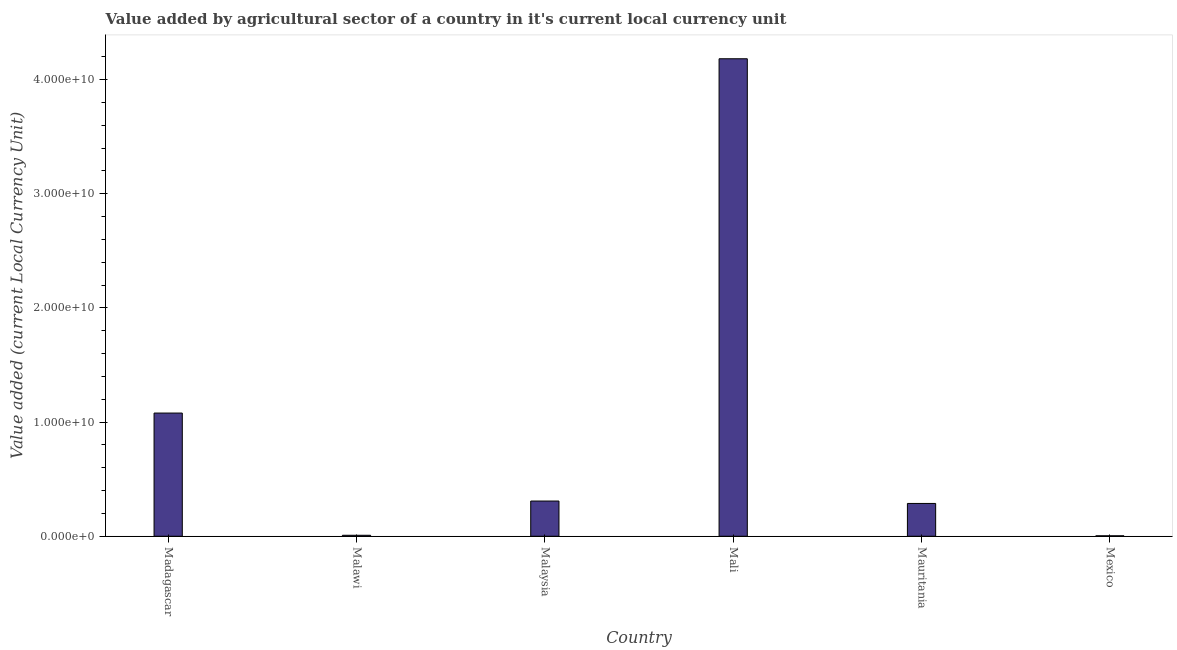Does the graph contain any zero values?
Provide a short and direct response. No. Does the graph contain grids?
Offer a terse response. No. What is the title of the graph?
Give a very brief answer. Value added by agricultural sector of a country in it's current local currency unit. What is the label or title of the X-axis?
Offer a terse response. Country. What is the label or title of the Y-axis?
Keep it short and to the point. Value added (current Local Currency Unit). What is the value added by agriculture sector in Mali?
Offer a very short reply. 4.18e+1. Across all countries, what is the maximum value added by agriculture sector?
Your answer should be very brief. 4.18e+1. Across all countries, what is the minimum value added by agriculture sector?
Make the answer very short. 3.90e+07. In which country was the value added by agriculture sector maximum?
Offer a very short reply. Mali. What is the sum of the value added by agriculture sector?
Your response must be concise. 5.87e+1. What is the difference between the value added by agriculture sector in Malawi and Mexico?
Your answer should be compact. 4.70e+07. What is the average value added by agriculture sector per country?
Offer a very short reply. 9.78e+09. What is the median value added by agriculture sector?
Your answer should be compact. 2.98e+09. In how many countries, is the value added by agriculture sector greater than 22000000000 LCU?
Give a very brief answer. 1. What is the ratio of the value added by agriculture sector in Malawi to that in Mexico?
Provide a short and direct response. 2.21. Is the value added by agriculture sector in Madagascar less than that in Malawi?
Provide a succinct answer. No. What is the difference between the highest and the second highest value added by agriculture sector?
Provide a succinct answer. 3.10e+1. What is the difference between the highest and the lowest value added by agriculture sector?
Ensure brevity in your answer.  4.18e+1. Are all the bars in the graph horizontal?
Your answer should be very brief. No. What is the difference between two consecutive major ticks on the Y-axis?
Offer a terse response. 1.00e+1. What is the Value added (current Local Currency Unit) in Madagascar?
Ensure brevity in your answer.  1.08e+1. What is the Value added (current Local Currency Unit) in Malawi?
Make the answer very short. 8.60e+07. What is the Value added (current Local Currency Unit) of Malaysia?
Give a very brief answer. 3.08e+09. What is the Value added (current Local Currency Unit) in Mali?
Provide a succinct answer. 4.18e+1. What is the Value added (current Local Currency Unit) in Mauritania?
Keep it short and to the point. 2.87e+09. What is the Value added (current Local Currency Unit) of Mexico?
Your answer should be very brief. 3.90e+07. What is the difference between the Value added (current Local Currency Unit) in Madagascar and Malawi?
Offer a very short reply. 1.07e+1. What is the difference between the Value added (current Local Currency Unit) in Madagascar and Malaysia?
Provide a short and direct response. 7.71e+09. What is the difference between the Value added (current Local Currency Unit) in Madagascar and Mali?
Your answer should be compact. -3.10e+1. What is the difference between the Value added (current Local Currency Unit) in Madagascar and Mauritania?
Ensure brevity in your answer.  7.92e+09. What is the difference between the Value added (current Local Currency Unit) in Madagascar and Mexico?
Offer a very short reply. 1.08e+1. What is the difference between the Value added (current Local Currency Unit) in Malawi and Malaysia?
Offer a terse response. -3.00e+09. What is the difference between the Value added (current Local Currency Unit) in Malawi and Mali?
Offer a very short reply. -4.17e+1. What is the difference between the Value added (current Local Currency Unit) in Malawi and Mauritania?
Make the answer very short. -2.79e+09. What is the difference between the Value added (current Local Currency Unit) in Malawi and Mexico?
Keep it short and to the point. 4.70e+07. What is the difference between the Value added (current Local Currency Unit) in Malaysia and Mali?
Make the answer very short. -3.87e+1. What is the difference between the Value added (current Local Currency Unit) in Malaysia and Mauritania?
Ensure brevity in your answer.  2.11e+08. What is the difference between the Value added (current Local Currency Unit) in Malaysia and Mexico?
Your response must be concise. 3.05e+09. What is the difference between the Value added (current Local Currency Unit) in Mali and Mauritania?
Make the answer very short. 3.90e+1. What is the difference between the Value added (current Local Currency Unit) in Mali and Mexico?
Offer a very short reply. 4.18e+1. What is the difference between the Value added (current Local Currency Unit) in Mauritania and Mexico?
Provide a short and direct response. 2.83e+09. What is the ratio of the Value added (current Local Currency Unit) in Madagascar to that in Malawi?
Make the answer very short. 125.49. What is the ratio of the Value added (current Local Currency Unit) in Madagascar to that in Malaysia?
Ensure brevity in your answer.  3.5. What is the ratio of the Value added (current Local Currency Unit) in Madagascar to that in Mali?
Make the answer very short. 0.26. What is the ratio of the Value added (current Local Currency Unit) in Madagascar to that in Mauritania?
Ensure brevity in your answer.  3.76. What is the ratio of the Value added (current Local Currency Unit) in Madagascar to that in Mexico?
Offer a very short reply. 276.73. What is the ratio of the Value added (current Local Currency Unit) in Malawi to that in Malaysia?
Your response must be concise. 0.03. What is the ratio of the Value added (current Local Currency Unit) in Malawi to that in Mali?
Offer a very short reply. 0. What is the ratio of the Value added (current Local Currency Unit) in Malawi to that in Mauritania?
Keep it short and to the point. 0.03. What is the ratio of the Value added (current Local Currency Unit) in Malawi to that in Mexico?
Your answer should be very brief. 2.21. What is the ratio of the Value added (current Local Currency Unit) in Malaysia to that in Mali?
Offer a very short reply. 0.07. What is the ratio of the Value added (current Local Currency Unit) in Malaysia to that in Mauritania?
Offer a very short reply. 1.07. What is the ratio of the Value added (current Local Currency Unit) in Malaysia to that in Mexico?
Your answer should be very brief. 79.1. What is the ratio of the Value added (current Local Currency Unit) in Mali to that in Mauritania?
Provide a short and direct response. 14.56. What is the ratio of the Value added (current Local Currency Unit) in Mali to that in Mexico?
Provide a succinct answer. 1072.56. What is the ratio of the Value added (current Local Currency Unit) in Mauritania to that in Mexico?
Provide a short and direct response. 73.68. 